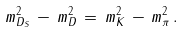Convert formula to latex. <formula><loc_0><loc_0><loc_500><loc_500>m _ { D _ { S } } ^ { 2 } \, - \, m _ { D } ^ { 2 } \, = \, m _ { K } ^ { 2 } \, - \, m _ { \pi } ^ { 2 } \, .</formula> 